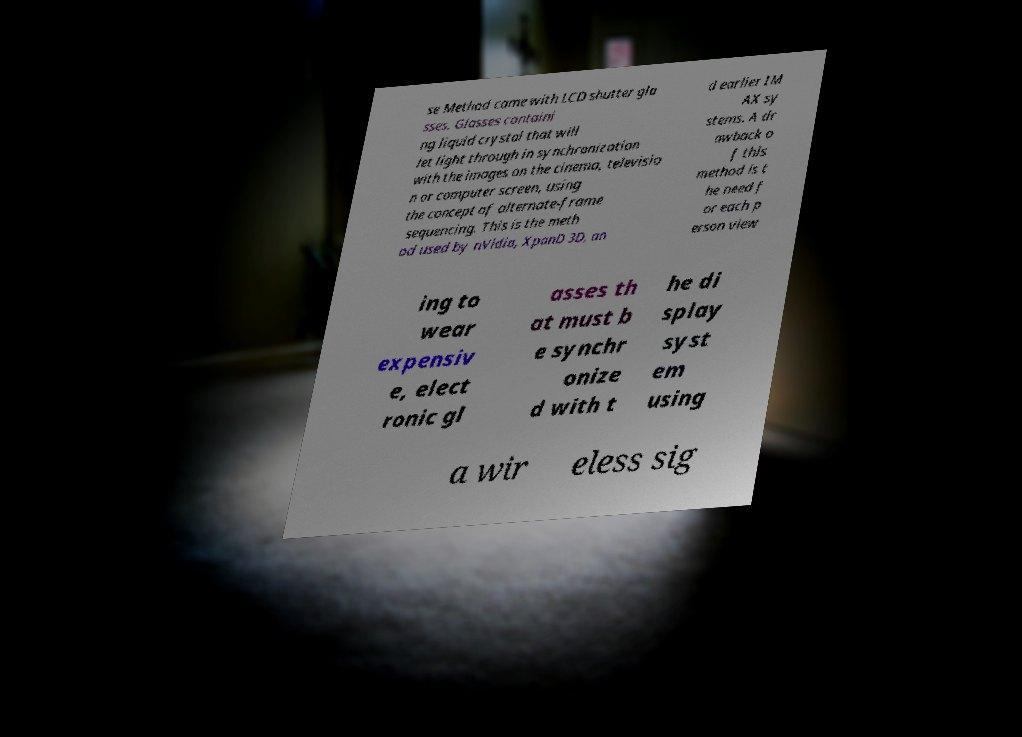Please read and relay the text visible in this image. What does it say? se Method came with LCD shutter gla sses. Glasses containi ng liquid crystal that will let light through in synchronization with the images on the cinema, televisio n or computer screen, using the concept of alternate-frame sequencing. This is the meth od used by nVidia, XpanD 3D, an d earlier IM AX sy stems. A dr awback o f this method is t he need f or each p erson view ing to wear expensiv e, elect ronic gl asses th at must b e synchr onize d with t he di splay syst em using a wir eless sig 